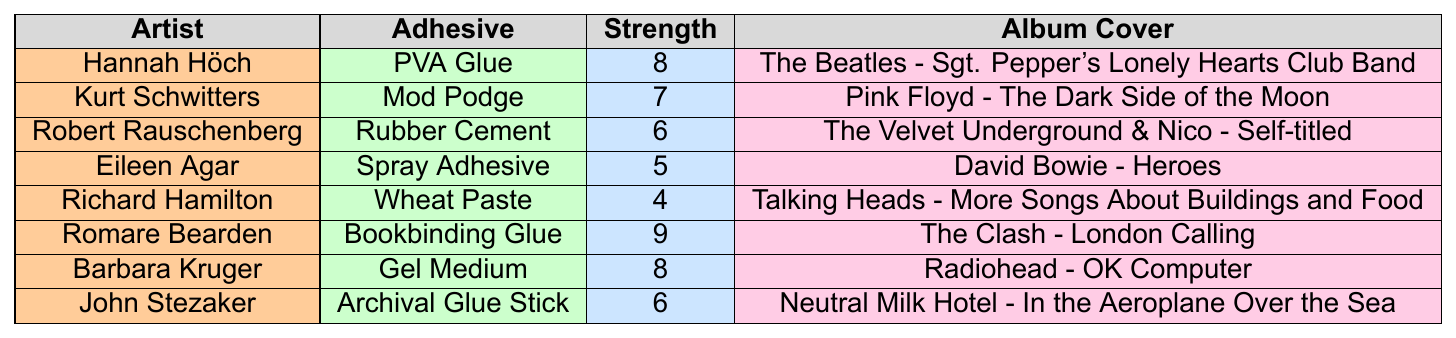What adhesive has the highest bonding strength? The bonding strengths listed for each adhesive show that Bookbinding Glue has the highest strength at 9.
Answer: Bookbinding Glue Which artist used Rubber Cement for their work? Referring to the table, Robert Rauschenberg is the artist associated with the use of Rubber Cement.
Answer: Robert Rauschenberg What is the bonding strength of Gel Medium? Gel Medium has a bonding strength of 8 according to the table.
Answer: 8 What is the average bonding strength of all adhesives listed? The bonding strengths are 8, 7, 6, 5, 4, 9, 8, 6. The sum is 53. There are 8 data points, so the average is 53/8 = 6.625.
Answer: 6.625 Did any artist use both Gel Medium and PVA Glue? According to the table, Barbara Kruger uses Gel Medium and Hannah Höch uses PVA Glue, which means no artist is reported to use both adhesives.
Answer: No What can be said about the relationship between bonding strength and album cover choices? By comparing bonding strengths, one can notice that stronger adhesives like Bookbinding Glue (strength 9) are paired with albums that might require high durability. However, reasoning about specific album choices based only on strength requires deeper context beyond the table.
Answer: It suggests stronger adhesives might favor more durable projects, but further context is needed Which artists used adhesives with bonding strengths below 6? From the table, the artists who used adhesives with strengths below 6 are Eileen Agar (5, Spray Adhesive) and Richard Hamilton (4, Wheat Paste).
Answer: Eileen Agar and Richard Hamilton How many adhesives scored a bonding strength greater than 7? The adhesives with bonding strengths greater than 7 are PVA Glue (8), Bookbinding Glue (9), and Gel Medium (8). In total, there are 3 adhesives.
Answer: 3 What adhesive is used by the artist known for "London Calling"? The artist associated with the album "London Calling" is Romare Bearden, who uses Bookbinding Glue.
Answer: Bookbinding Glue What is the second lowest bonding strength and the corresponding adhesive? The second lowest bonding strength is 5, which corresponds to the adhesive Spray Adhesive.
Answer: Spray Adhesive Which album is associated with the PVA Glue user? The artist Hannah Höch is associated with PVA Glue, and the album linked to her is "The Beatles - Sgt. Pepper's Lonely Hearts Club Band."
Answer: The Beatles - Sgt. Pepper's Lonely Hearts Club Band 